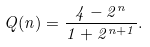Convert formula to latex. <formula><loc_0><loc_0><loc_500><loc_500>Q ( n ) = \frac { 4 - 2 ^ { n } } { 1 + 2 ^ { n + 1 } } .</formula> 